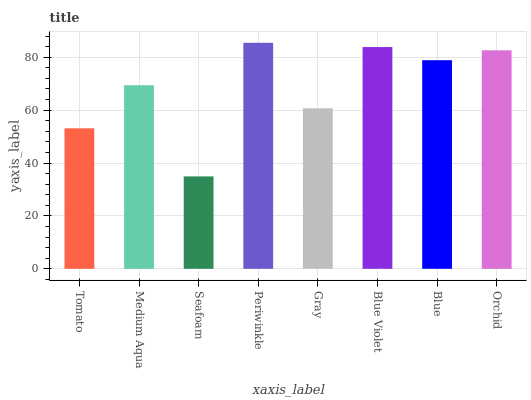Is Seafoam the minimum?
Answer yes or no. Yes. Is Periwinkle the maximum?
Answer yes or no. Yes. Is Medium Aqua the minimum?
Answer yes or no. No. Is Medium Aqua the maximum?
Answer yes or no. No. Is Medium Aqua greater than Tomato?
Answer yes or no. Yes. Is Tomato less than Medium Aqua?
Answer yes or no. Yes. Is Tomato greater than Medium Aqua?
Answer yes or no. No. Is Medium Aqua less than Tomato?
Answer yes or no. No. Is Blue the high median?
Answer yes or no. Yes. Is Medium Aqua the low median?
Answer yes or no. Yes. Is Medium Aqua the high median?
Answer yes or no. No. Is Blue Violet the low median?
Answer yes or no. No. 